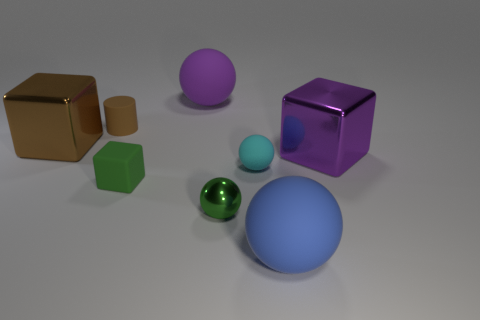There is a big thing to the left of the cylinder; what is its material?
Provide a short and direct response. Metal. Do the small cylinder and the large brown block have the same material?
Your answer should be compact. No. There is a large shiny thing that is to the right of the blue matte thing; what number of large purple metal blocks are to the left of it?
Provide a short and direct response. 0. Is there another large rubber thing that has the same shape as the large purple rubber object?
Provide a succinct answer. Yes. Do the big matte thing that is in front of the big purple matte object and the purple thing on the left side of the tiny shiny ball have the same shape?
Make the answer very short. Yes. What is the shape of the tiny object that is to the left of the purple rubber sphere and in front of the purple shiny thing?
Give a very brief answer. Cube. Are there any other brown objects that have the same size as the brown shiny thing?
Your answer should be very brief. No. There is a tiny rubber block; is its color the same as the metallic sphere that is left of the large blue rubber ball?
Provide a short and direct response. Yes. What is the tiny brown cylinder made of?
Keep it short and to the point. Rubber. What color is the big matte thing that is behind the big brown metallic object?
Ensure brevity in your answer.  Purple. 